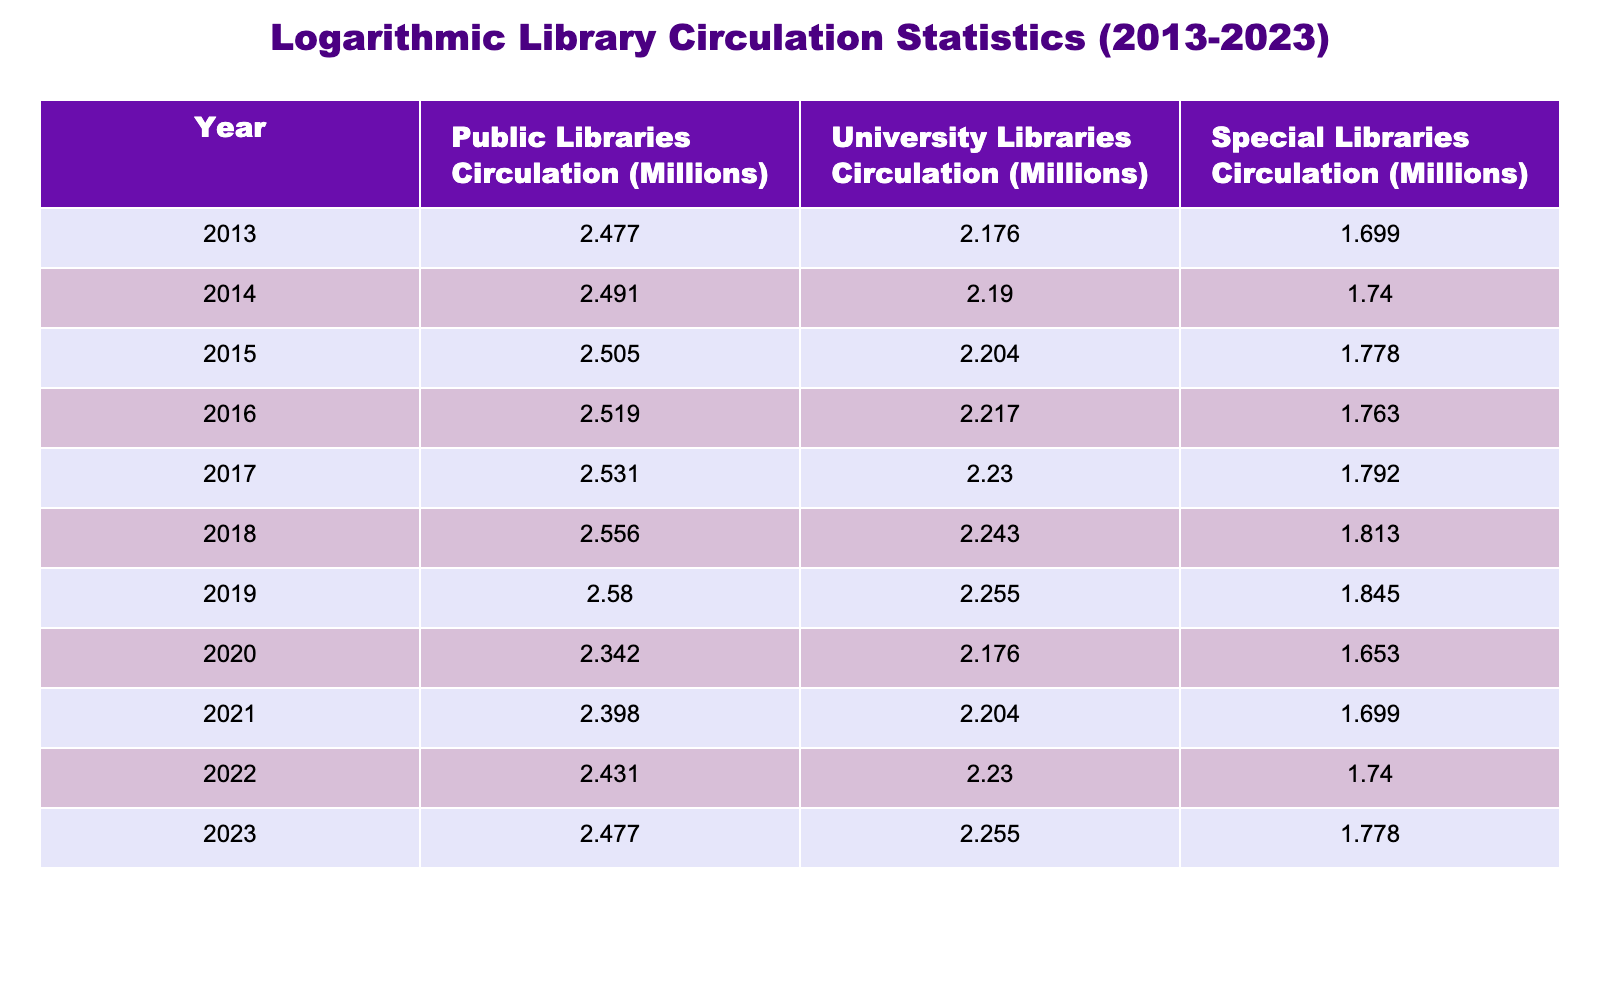What is the logarithmic value of public libraries' circulation in 2019? The table shows that the public libraries' circulation in 2019 is 380 million. Taking the logarithm base 10, log10(380) is approximately 2.579.
Answer: 2.579 What was the total circulation for university libraries in 2020 and 2021? The table indicates that the university libraries' circulation was 150 million in 2020 and 160 million in 2021. Adding these two values gives 150 + 160 = 310 million. The logarithmic value is log10(310) which is approximately 2.491.
Answer: 2.491 Did the circulation of special libraries increase every year from 2013 to 2023? By examining the table, we see that the circulation for special libraries increased from 50 million in 2013 to 70 million in 2019 but then decreased to 45 million in 2020 and fluctuated until 60 million in 2023. Therefore, it did not increase every year.
Answer: No What was the average circulation of public libraries over the decade? The circulation values from 2013 to 2023 are 300, 310, 320, 330, 340, 360, 380, 220, 250, 270, and 300 million. Adding these up gives a total of 3,257 million. Dividing this by the number of years (11) gives an average of 3,257 / 11 ≈ 296.09 million. The logarithmic value is log10(296.09) which is approximately 2.471.
Answer: 2.471 What year saw the highest logarithmic value of university library circulation? The year 2023 had the highest university library circulation at 180 million. The logarithmic transformation of this value gives log10(180) which is approximately 2.255.
Answer: 2.255 How much did the circulation of public libraries decrease from 2019 to 2020? In 2019, the public libraries' circulation was 380 million, and in 2020 it dropped to 220 million. The difference is 380 - 220 = 160 million. The logarithmic value of this decrease is log10(160), which is approximately 2.204.
Answer: 2.204 